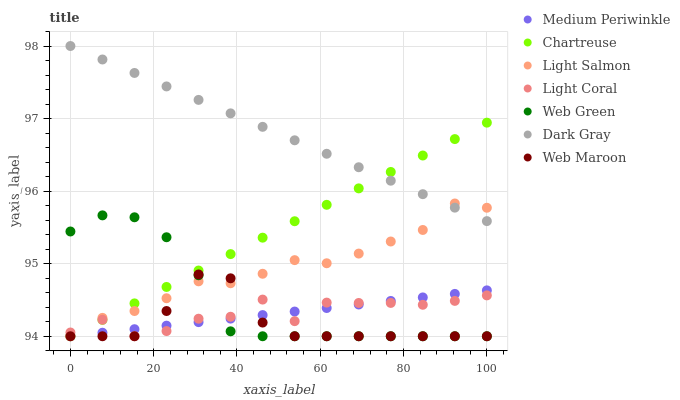Does Web Maroon have the minimum area under the curve?
Answer yes or no. Yes. Does Dark Gray have the maximum area under the curve?
Answer yes or no. Yes. Does Light Salmon have the minimum area under the curve?
Answer yes or no. No. Does Light Salmon have the maximum area under the curve?
Answer yes or no. No. Is Chartreuse the smoothest?
Answer yes or no. Yes. Is Light Coral the roughest?
Answer yes or no. Yes. Is Light Salmon the smoothest?
Answer yes or no. No. Is Light Salmon the roughest?
Answer yes or no. No. Does Light Salmon have the lowest value?
Answer yes or no. Yes. Does Dark Gray have the highest value?
Answer yes or no. Yes. Does Light Salmon have the highest value?
Answer yes or no. No. Is Medium Periwinkle less than Dark Gray?
Answer yes or no. Yes. Is Dark Gray greater than Web Green?
Answer yes or no. Yes. Does Web Maroon intersect Light Salmon?
Answer yes or no. Yes. Is Web Maroon less than Light Salmon?
Answer yes or no. No. Is Web Maroon greater than Light Salmon?
Answer yes or no. No. Does Medium Periwinkle intersect Dark Gray?
Answer yes or no. No. 